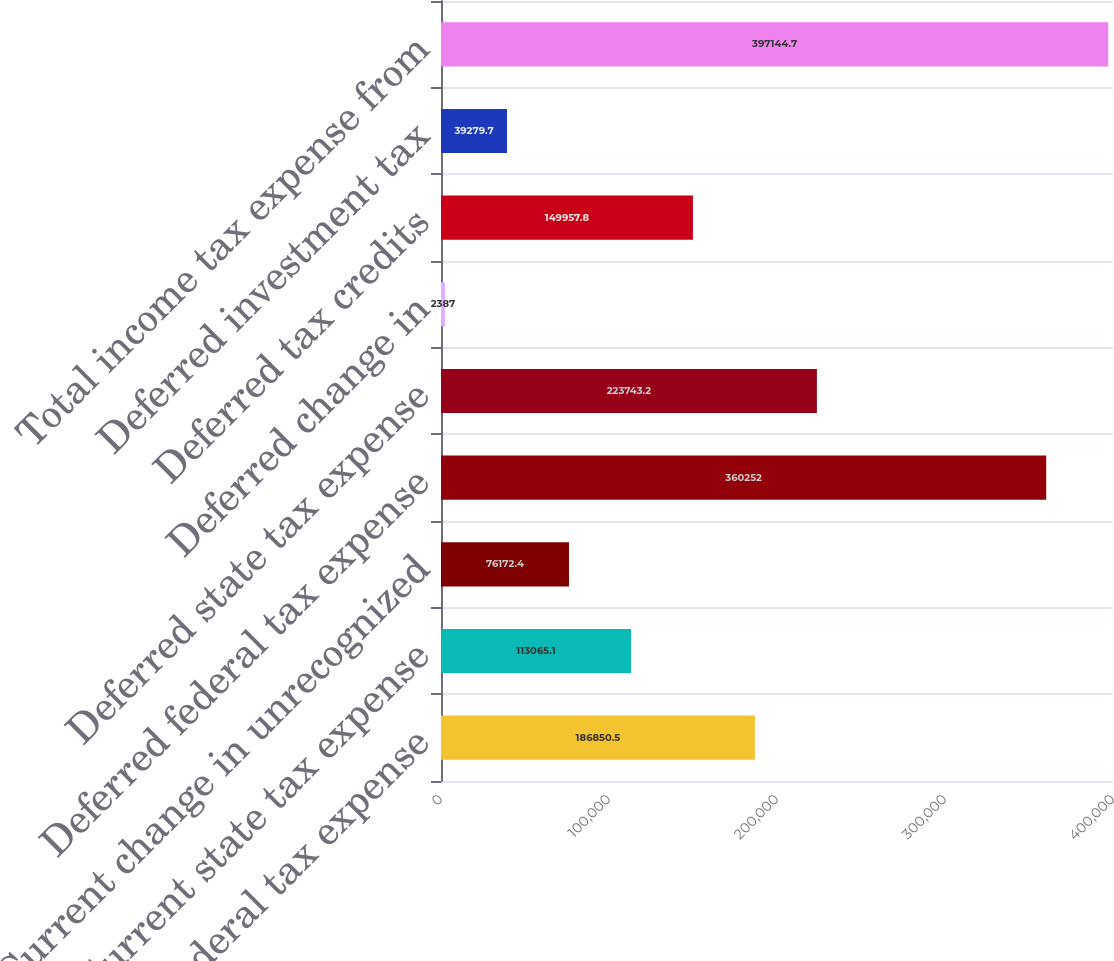<chart> <loc_0><loc_0><loc_500><loc_500><bar_chart><fcel>Current federal tax expense<fcel>Current state tax expense<fcel>Current change in unrecognized<fcel>Deferred federal tax expense<fcel>Deferred state tax expense<fcel>Deferred change in<fcel>Deferred tax credits<fcel>Deferred investment tax<fcel>Total income tax expense from<nl><fcel>186850<fcel>113065<fcel>76172.4<fcel>360252<fcel>223743<fcel>2387<fcel>149958<fcel>39279.7<fcel>397145<nl></chart> 